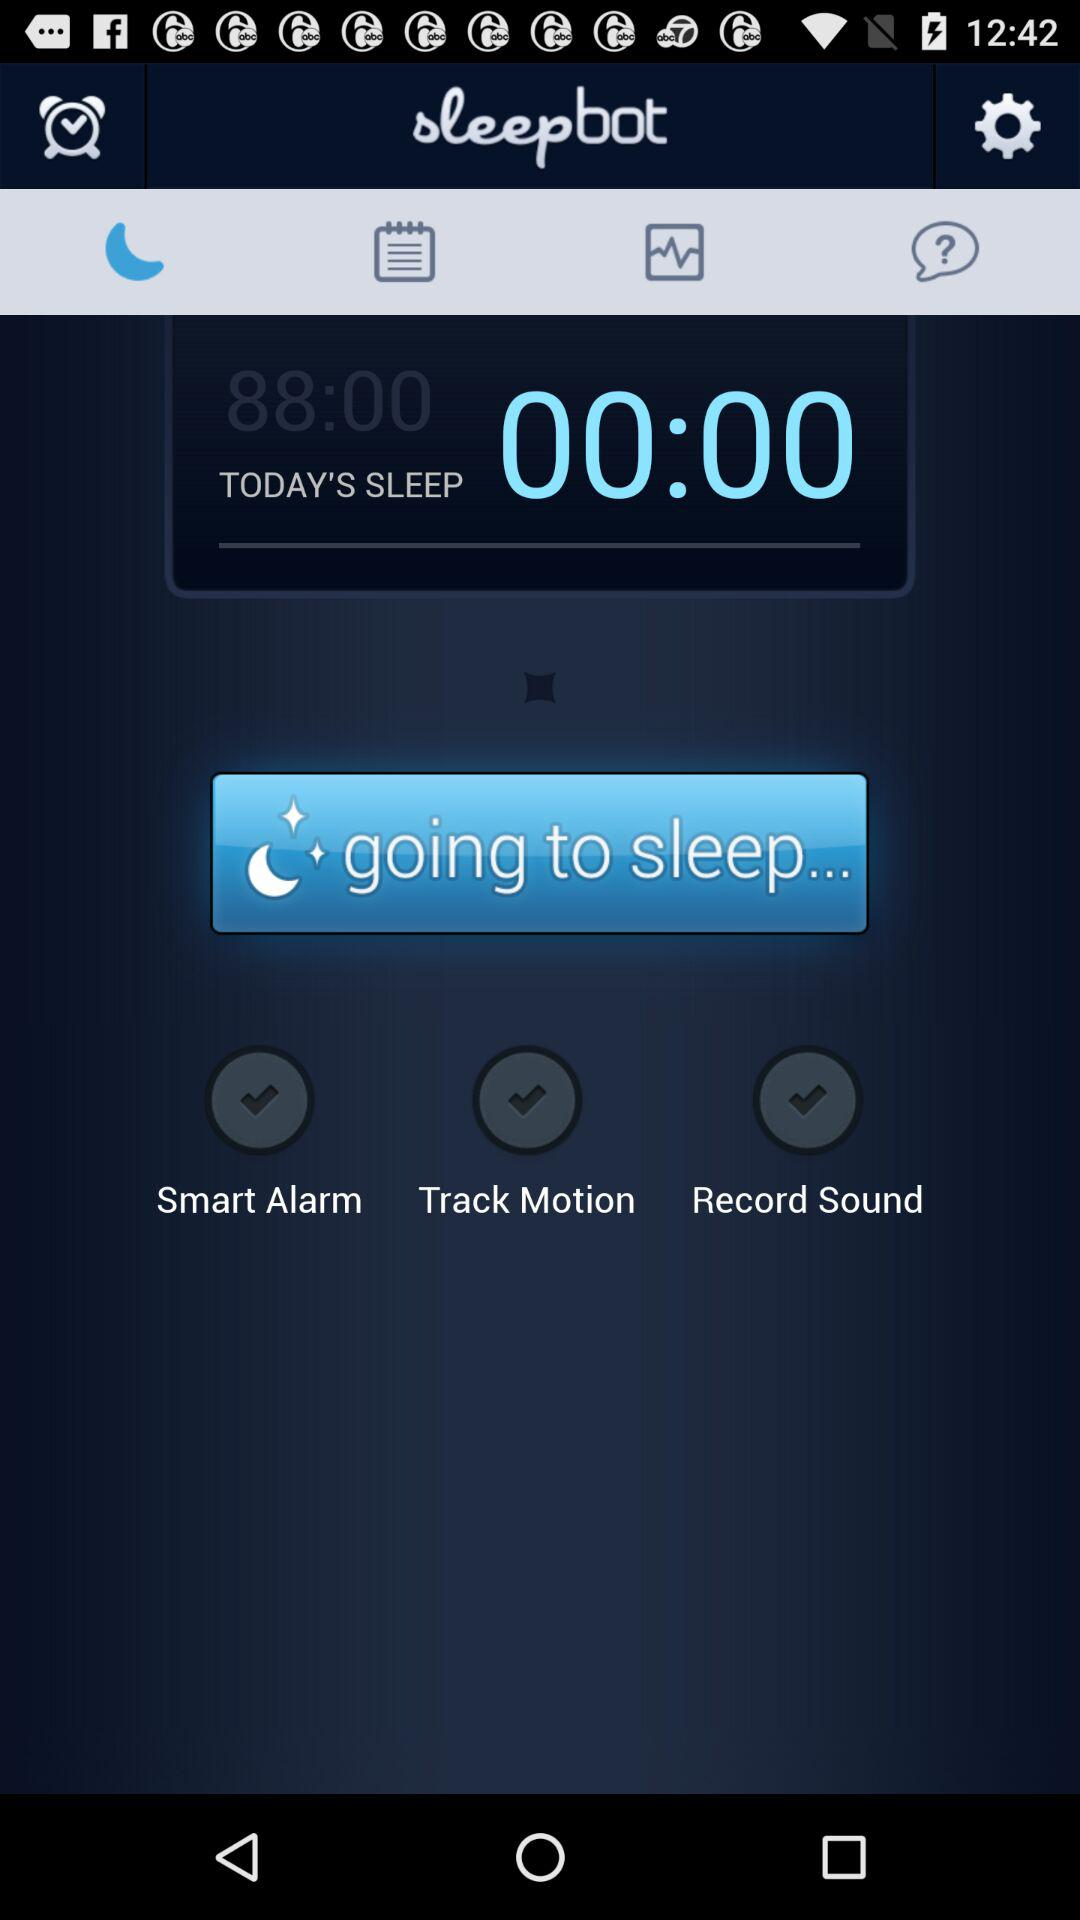How many features are enabled for my sleep tracking?
Answer the question using a single word or phrase. 3 